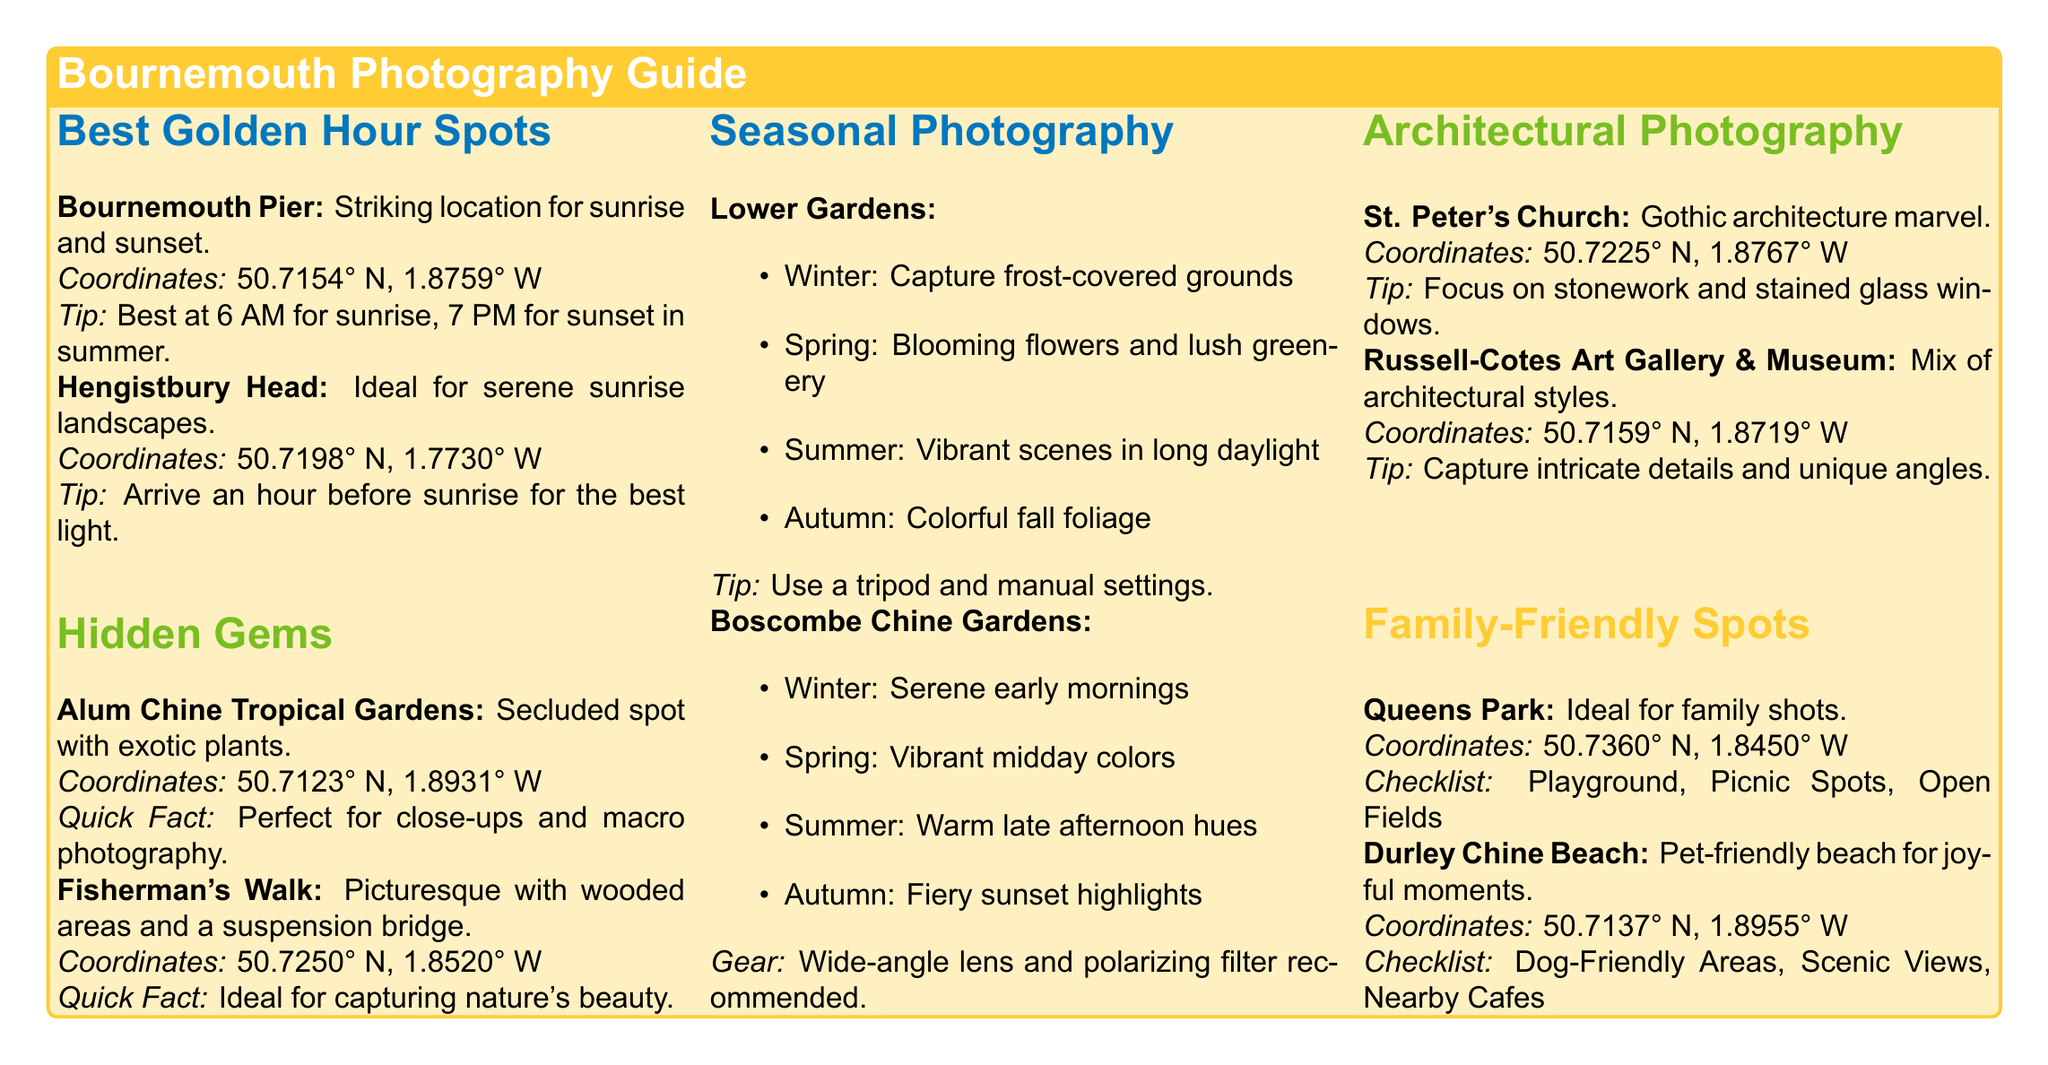what is the best location for sunrise photography? The document states that Bournemouth Pier is a striking location for sunrise photography.
Answer: Bournemouth Pier what are the coordinates for Hengistbury Head? The document provides specific coordinates for Hengistbury Head as 50.7198° N, 1.7730° W.
Answer: 50.7198° N, 1.7730° W which season is recommended for vibrant scenes in Lower Gardens? The document mentions summer as the season for vibrant scenes in Lower Gardens.
Answer: Summer what is a quick fact about Alum Chine Tropical Gardens? The document describes Alum Chine Tropical Gardens as a perfect spot for close-ups and macro photography.
Answer: Perfect for close-ups and macro photography what photography gear is recommended for capturing Boscombe Chine Gardens? The document suggests using a wide-angle lens and polarizing filter for capturing Boscombe Chine Gardens.
Answer: Wide-angle lens and polarizing filter which architectural structure is known for its Gothic architecture? The document identifies St. Peter's Church as an architectural structure known for its Gothic architecture.
Answer: St. Peter's Church how many family-friendly spots are mentioned in the document? The document lists two family-friendly spots, which are Queens Park and Durley Chine Beach.
Answer: Two what should photographers focus on when capturing Russell-Cotes Art Gallery & Museum? The document recommends focusing on intricate details and unique angles when photographing Russell-Cotes Art Gallery & Museum.
Answer: Intricate details and unique angles when is the best time for sunset photography at Bournemouth Pier during summer? The document suggests that sunset photography is best at 7 PM during summer at Bournemouth Pier.
Answer: 7 PM 